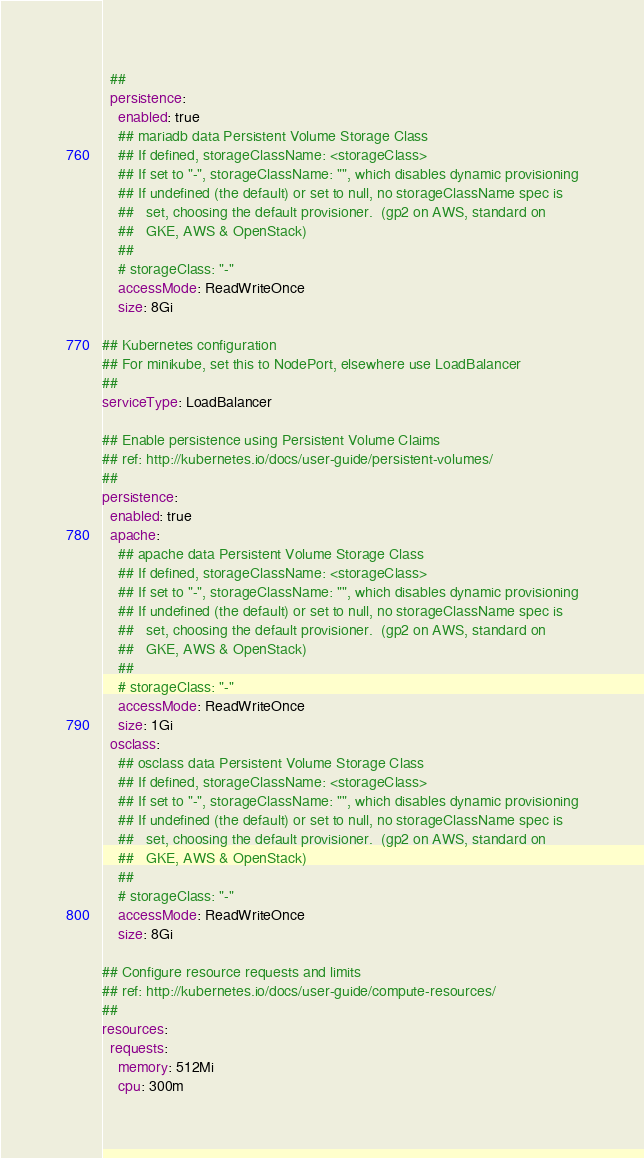<code> <loc_0><loc_0><loc_500><loc_500><_YAML_>  ##
  persistence:
    enabled: true
    ## mariadb data Persistent Volume Storage Class
    ## If defined, storageClassName: <storageClass>
    ## If set to "-", storageClassName: "", which disables dynamic provisioning
    ## If undefined (the default) or set to null, no storageClassName spec is
    ##   set, choosing the default provisioner.  (gp2 on AWS, standard on
    ##   GKE, AWS & OpenStack)
    ##
    # storageClass: "-"
    accessMode: ReadWriteOnce
    size: 8Gi

## Kubernetes configuration
## For minikube, set this to NodePort, elsewhere use LoadBalancer
##
serviceType: LoadBalancer

## Enable persistence using Persistent Volume Claims
## ref: http://kubernetes.io/docs/user-guide/persistent-volumes/
##
persistence:
  enabled: true
  apache:
    ## apache data Persistent Volume Storage Class
    ## If defined, storageClassName: <storageClass>
    ## If set to "-", storageClassName: "", which disables dynamic provisioning
    ## If undefined (the default) or set to null, no storageClassName spec is
    ##   set, choosing the default provisioner.  (gp2 on AWS, standard on
    ##   GKE, AWS & OpenStack)
    ##
    # storageClass: "-"
    accessMode: ReadWriteOnce
    size: 1Gi
  osclass:
    ## osclass data Persistent Volume Storage Class
    ## If defined, storageClassName: <storageClass>
    ## If set to "-", storageClassName: "", which disables dynamic provisioning
    ## If undefined (the default) or set to null, no storageClassName spec is
    ##   set, choosing the default provisioner.  (gp2 on AWS, standard on
    ##   GKE, AWS & OpenStack)
    ##
    # storageClass: "-"
    accessMode: ReadWriteOnce
    size: 8Gi

## Configure resource requests and limits
## ref: http://kubernetes.io/docs/user-guide/compute-resources/
##
resources:
  requests:
    memory: 512Mi
    cpu: 300m
</code> 